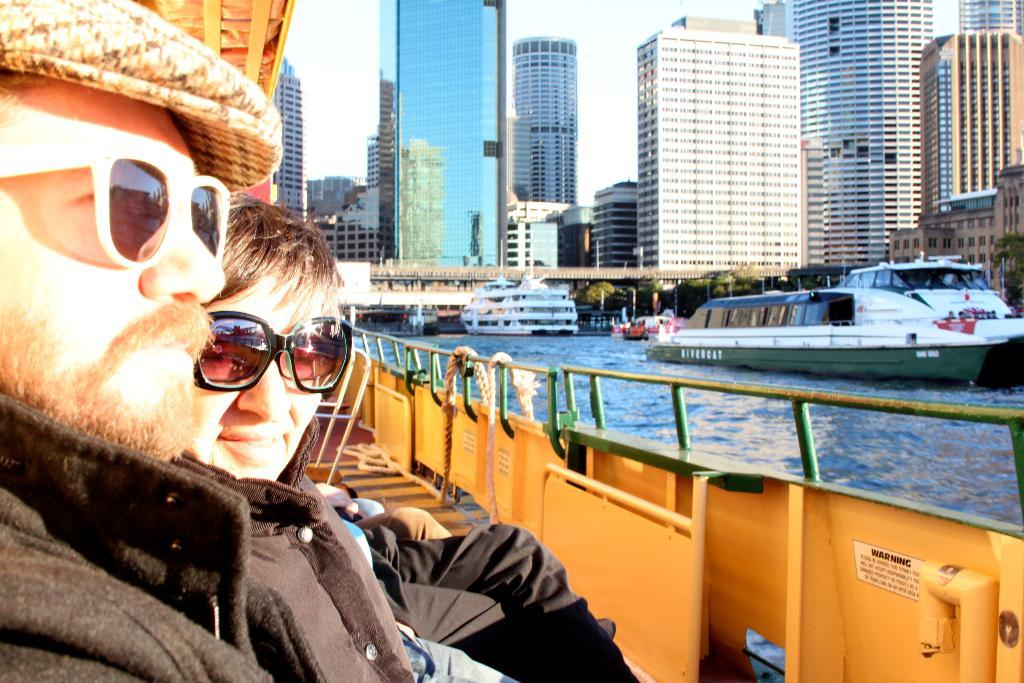What is the main subject of the image? The main subject of the image is ships on the water. Are there any people present in the image? Yes, there are people on the ships in the image. What type of structures can be seen in the background of the image? Tower buildings are visible in the image. Is there any infrastructure connecting the land masses in the image? Yes, there is a bridge in the image. What type of protest is taking place on the ships in the image? There is no protest taking place on the ships in the image; it only shows ships on the water with people on board. 